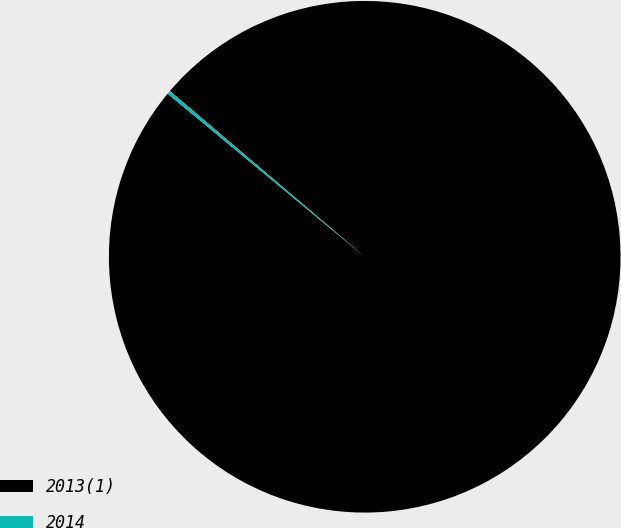Convert chart to OTSL. <chart><loc_0><loc_0><loc_500><loc_500><pie_chart><fcel>2013(1)<fcel>2014<nl><fcel>99.78%<fcel>0.22%<nl></chart> 